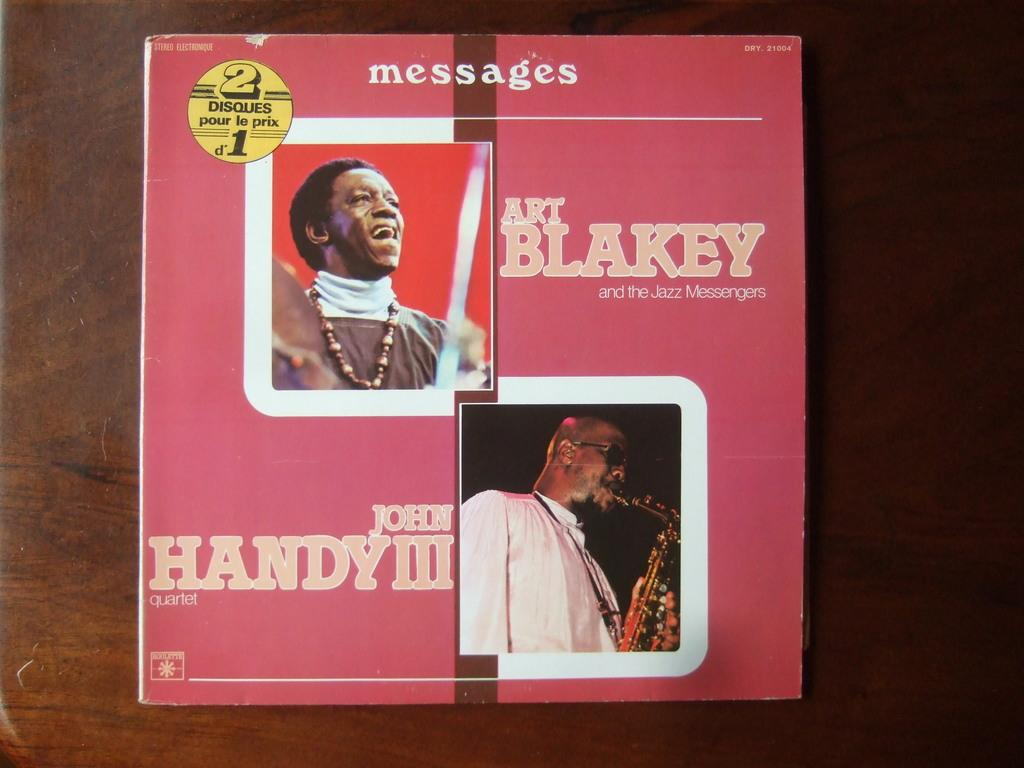<image>
Share a concise interpretation of the image provided. a disc booklet that says 'messages' at the top 